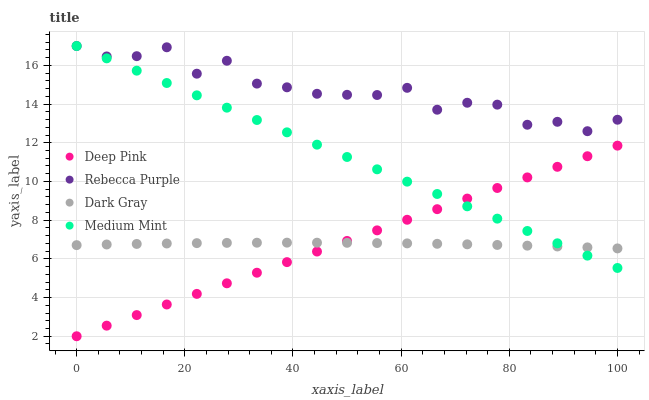Does Dark Gray have the minimum area under the curve?
Answer yes or no. Yes. Does Rebecca Purple have the maximum area under the curve?
Answer yes or no. Yes. Does Medium Mint have the minimum area under the curve?
Answer yes or no. No. Does Medium Mint have the maximum area under the curve?
Answer yes or no. No. Is Deep Pink the smoothest?
Answer yes or no. Yes. Is Rebecca Purple the roughest?
Answer yes or no. Yes. Is Medium Mint the smoothest?
Answer yes or no. No. Is Medium Mint the roughest?
Answer yes or no. No. Does Deep Pink have the lowest value?
Answer yes or no. Yes. Does Medium Mint have the lowest value?
Answer yes or no. No. Does Rebecca Purple have the highest value?
Answer yes or no. Yes. Does Deep Pink have the highest value?
Answer yes or no. No. Is Deep Pink less than Rebecca Purple?
Answer yes or no. Yes. Is Rebecca Purple greater than Deep Pink?
Answer yes or no. Yes. Does Medium Mint intersect Deep Pink?
Answer yes or no. Yes. Is Medium Mint less than Deep Pink?
Answer yes or no. No. Is Medium Mint greater than Deep Pink?
Answer yes or no. No. Does Deep Pink intersect Rebecca Purple?
Answer yes or no. No. 